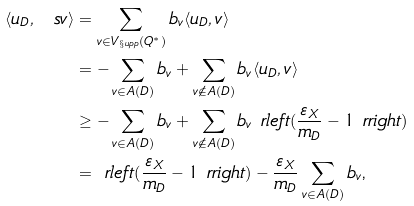Convert formula to latex. <formula><loc_0><loc_0><loc_500><loc_500>\langle u _ { D } , \ s v \rangle & = \sum _ { v \in V _ { \S u p p } ( Q ^ { * } ) } b _ { v } \langle u _ { D } , v \rangle \\ & = - \sum _ { v \in A ( D ) } b _ { v } + \sum _ { v \notin A ( D ) } b _ { v } \langle u _ { D } , v \rangle \\ & \geq - \sum _ { v \in A ( D ) } b _ { v } + \sum _ { v \notin A ( D ) } b _ { v } \ r l e f t ( \frac { \varepsilon _ { X } } { m _ { D } } - 1 \ r r i g h t ) \\ & = \ r l e f t ( \frac { \varepsilon _ { X } } { m _ { D } } - 1 \ r r i g h t ) - \frac { \varepsilon _ { X } } { m _ { D } } \sum _ { v \in A ( D ) } b _ { v } \text {,}</formula> 